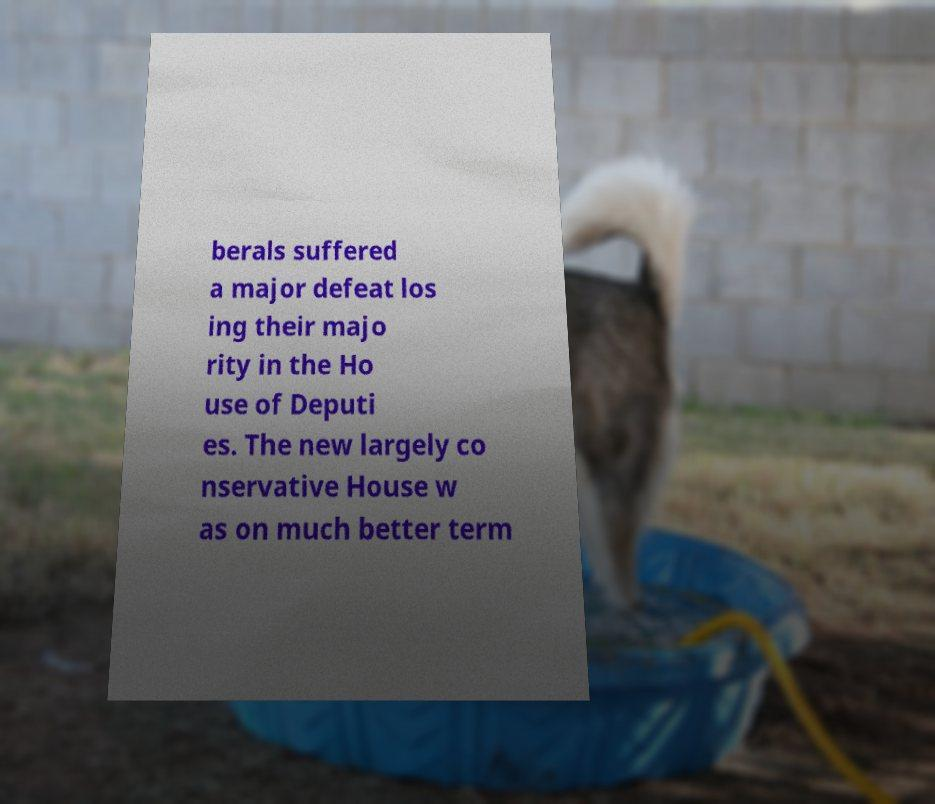There's text embedded in this image that I need extracted. Can you transcribe it verbatim? berals suffered a major defeat los ing their majo rity in the Ho use of Deputi es. The new largely co nservative House w as on much better term 